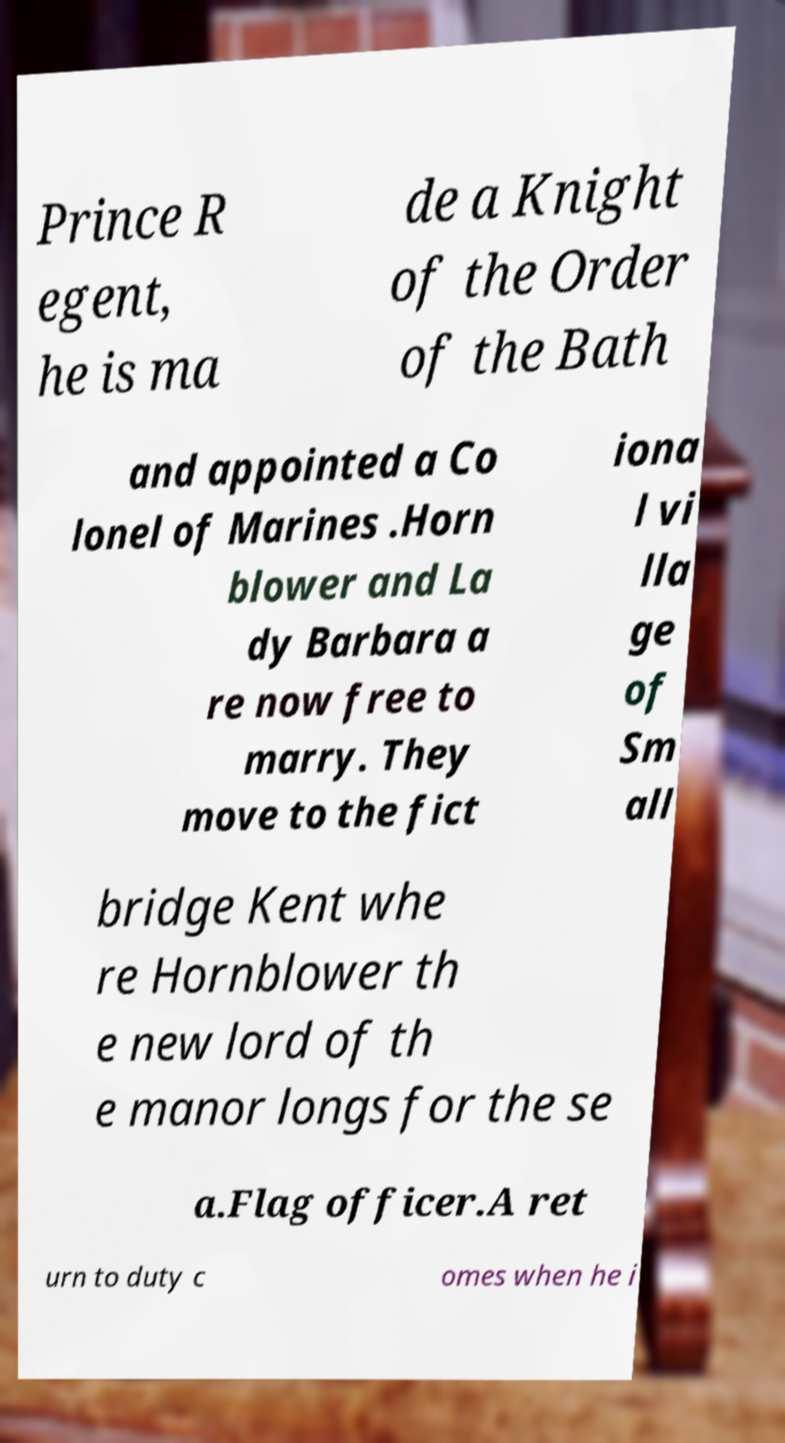Please identify and transcribe the text found in this image. Prince R egent, he is ma de a Knight of the Order of the Bath and appointed a Co lonel of Marines .Horn blower and La dy Barbara a re now free to marry. They move to the fict iona l vi lla ge of Sm all bridge Kent whe re Hornblower th e new lord of th e manor longs for the se a.Flag officer.A ret urn to duty c omes when he i 